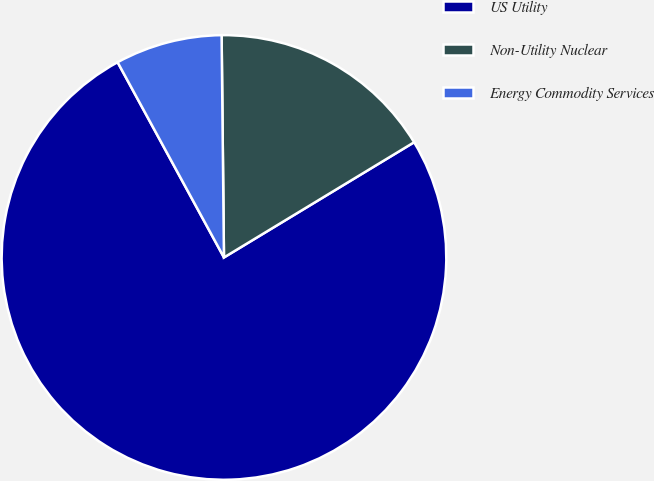<chart> <loc_0><loc_0><loc_500><loc_500><pie_chart><fcel>US Utility<fcel>Non-Utility Nuclear<fcel>Energy Commodity Services<nl><fcel>75.73%<fcel>16.5%<fcel>7.77%<nl></chart> 